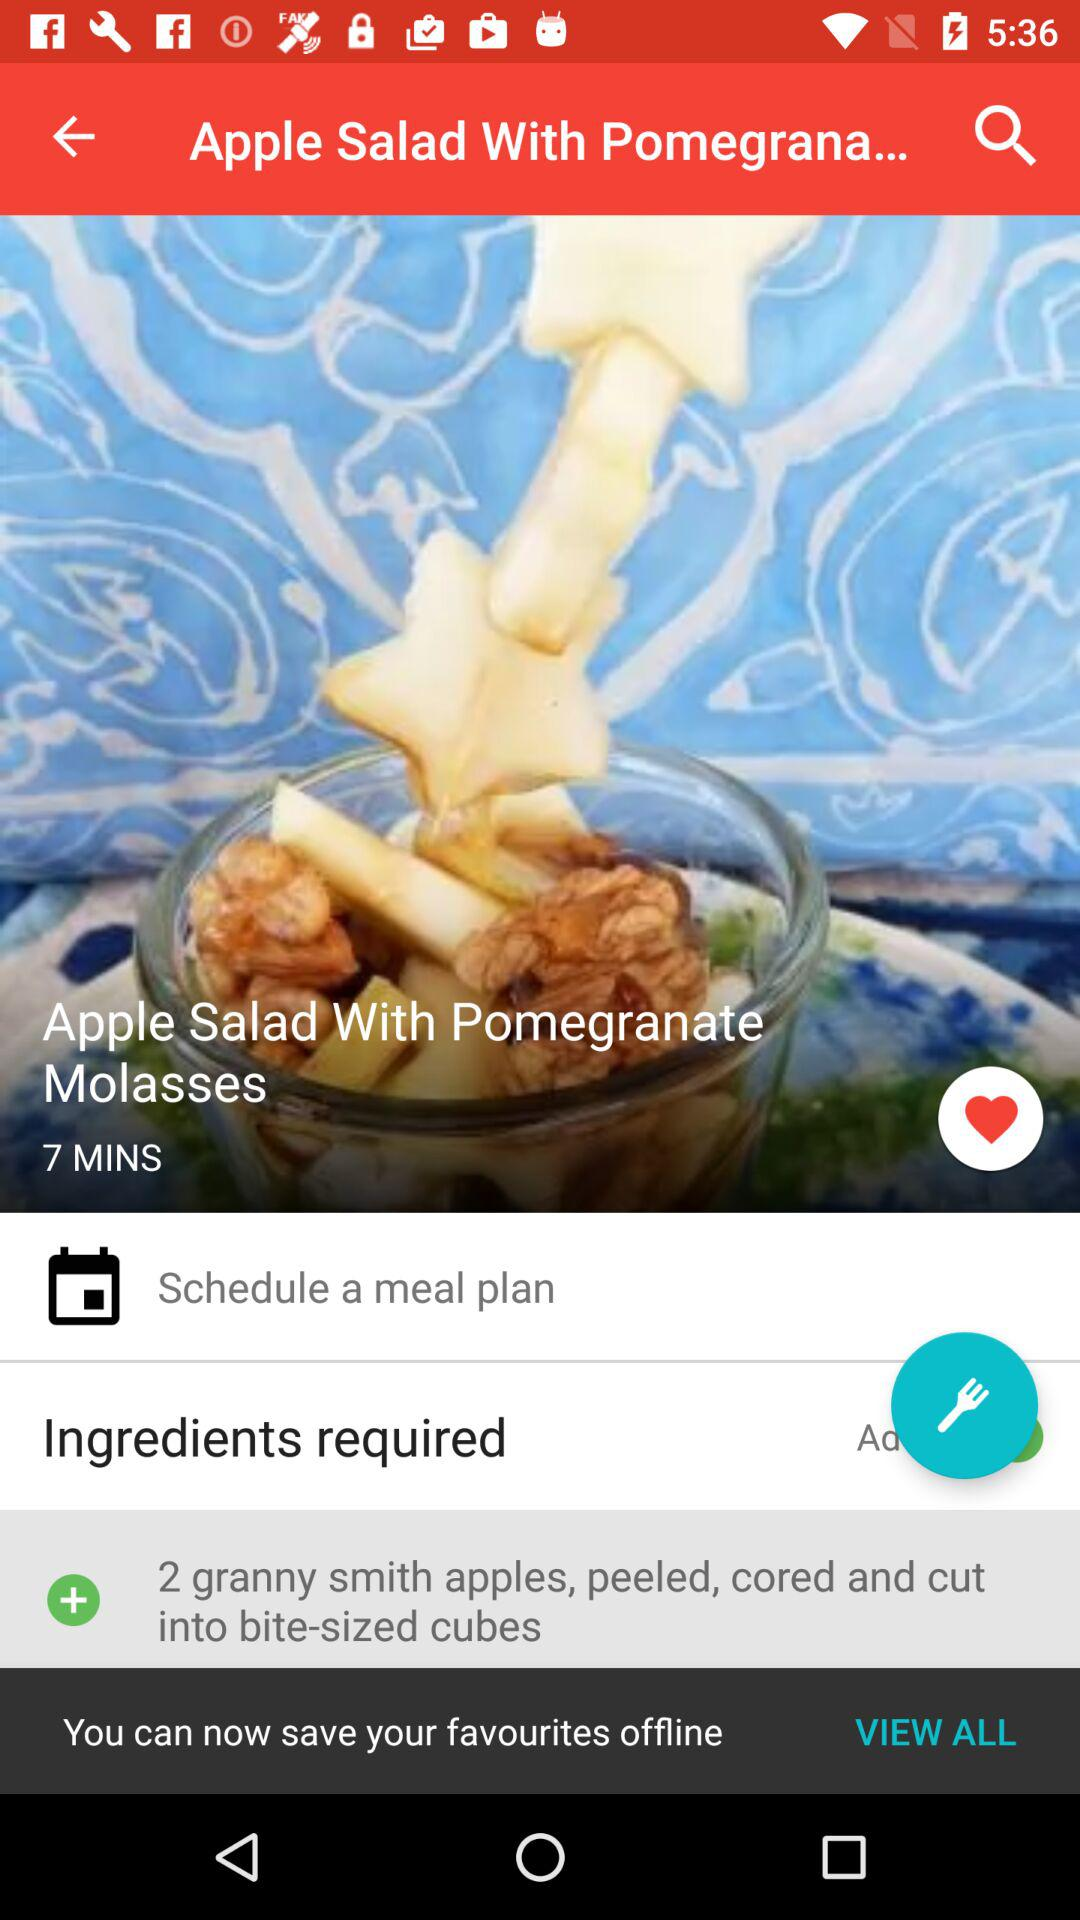What are the ingredients required for apple salad? The ingredients are "2 granny smith apples, peeled, cored and cut into bite-sized cubes". 